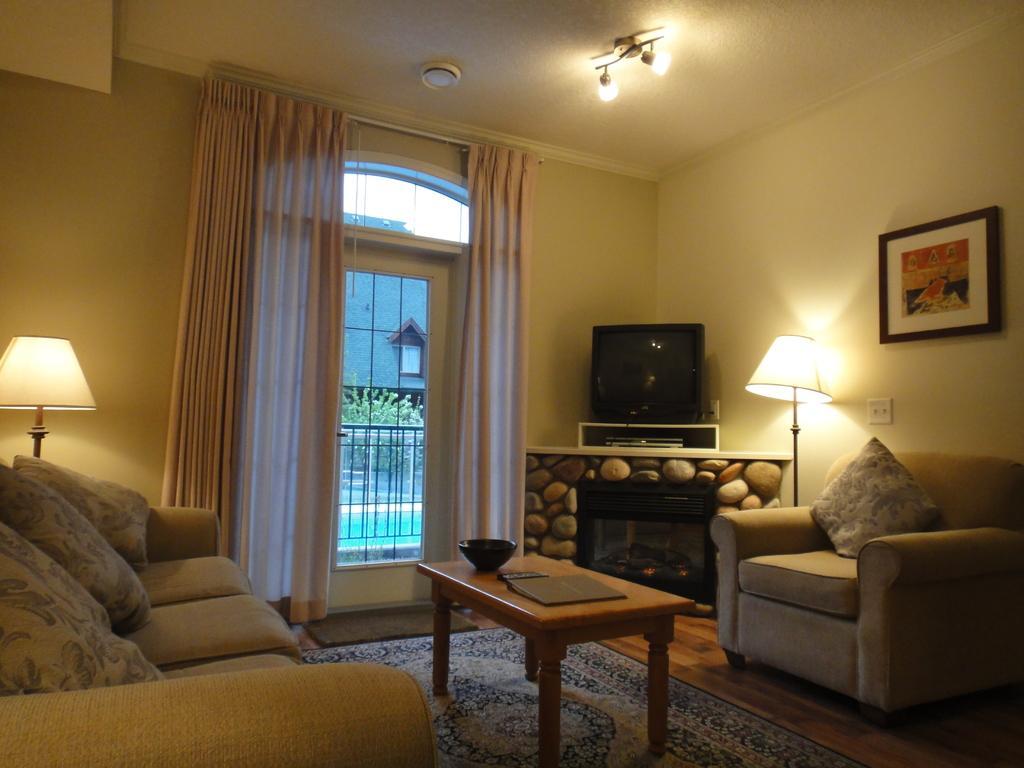Could you give a brief overview of what you see in this image? This picture is taken in a room which is well furnished with a sofa center table floor mat on the floor at the right side a lamp and a wall frame is changed to the wall in the corner a television, in the center a white colour curtain and a window,outside the window there are some plants and a building the left side one lamp is there and on the sofa there are cushions on the roof two lights are on. 